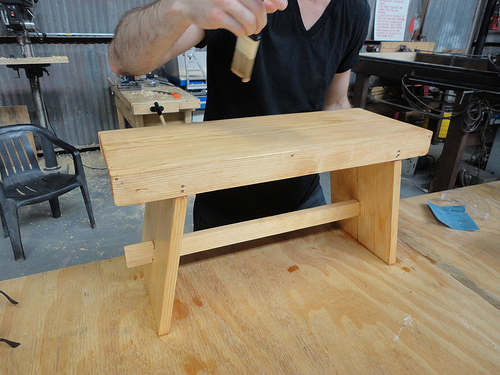<image>
Is there a man behind the table? Yes. From this viewpoint, the man is positioned behind the table, with the table partially or fully occluding the man. Is there a man in front of the chair? Yes. The man is positioned in front of the chair, appearing closer to the camera viewpoint. 